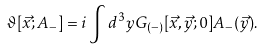Convert formula to latex. <formula><loc_0><loc_0><loc_500><loc_500>\vartheta [ \vec { x } ; A _ { - } ] = i \int d ^ { 3 } y G _ { ( - ) } [ \vec { x } , \vec { y } ; 0 ] A _ { - } ( \vec { y } ) .</formula> 